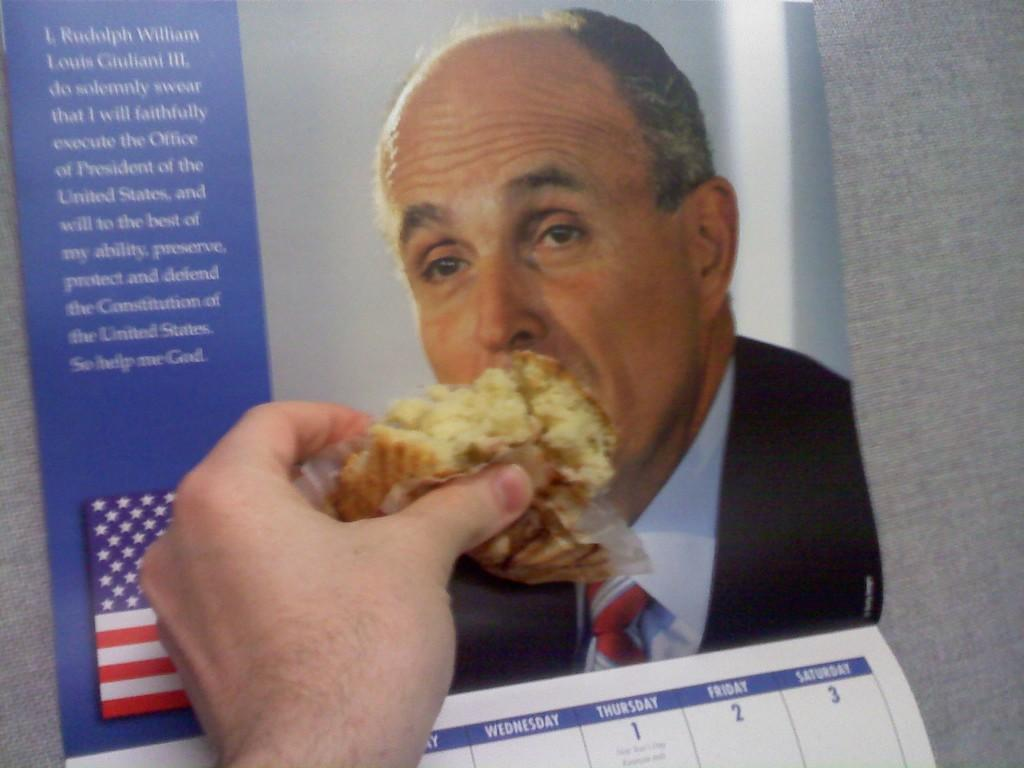<image>
Offer a succinct explanation of the picture presented. A person holds food in front of a picture of a Rudolph Giulani's face, making it look like he is eating it. 